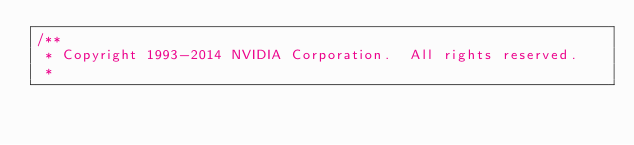Convert code to text. <code><loc_0><loc_0><loc_500><loc_500><_Cuda_>/**
 * Copyright 1993-2014 NVIDIA Corporation.  All rights reserved.
 *</code> 